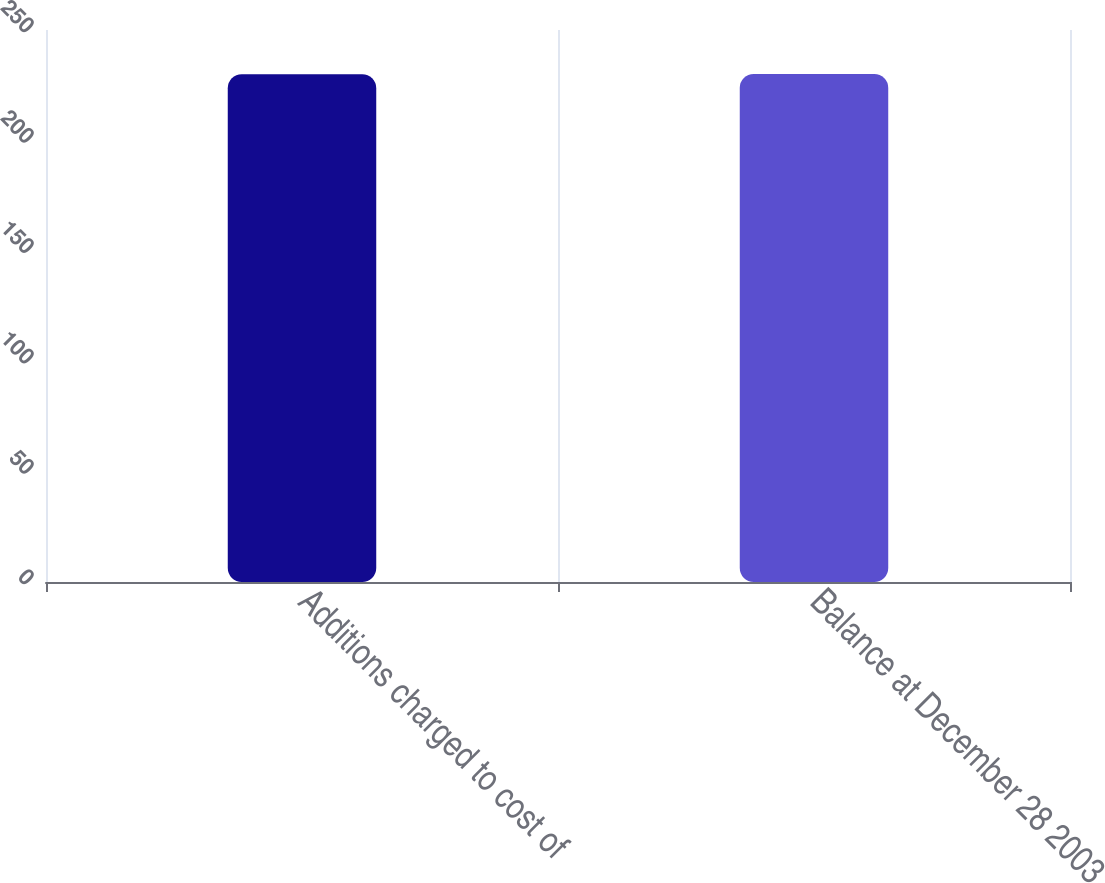Convert chart to OTSL. <chart><loc_0><loc_0><loc_500><loc_500><bar_chart><fcel>Additions charged to cost of<fcel>Balance at December 28 2003<nl><fcel>230<fcel>230.1<nl></chart> 